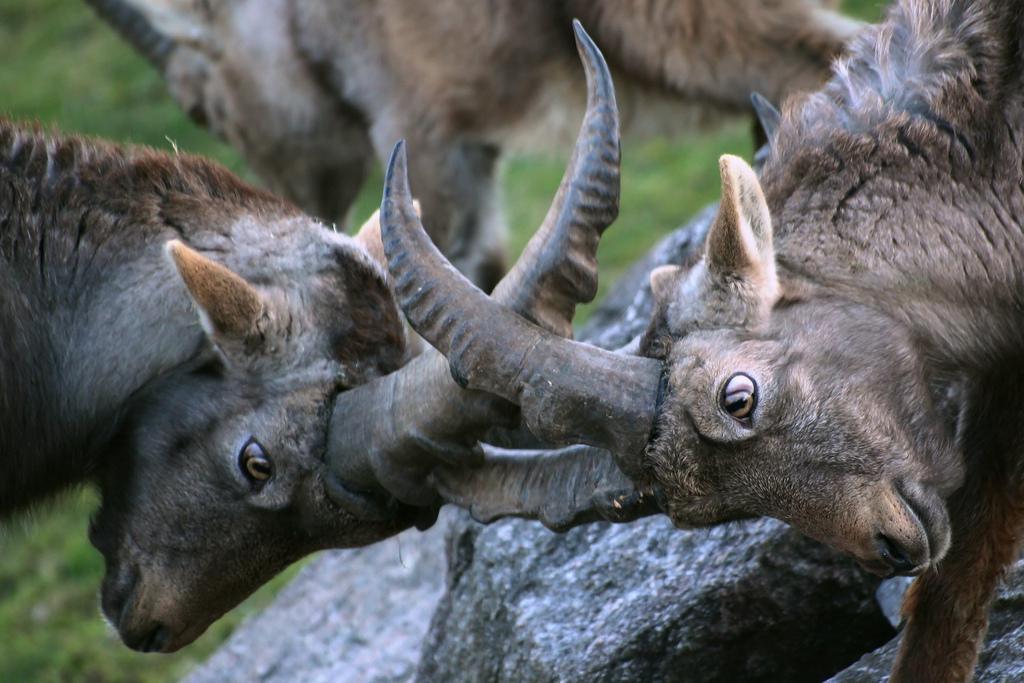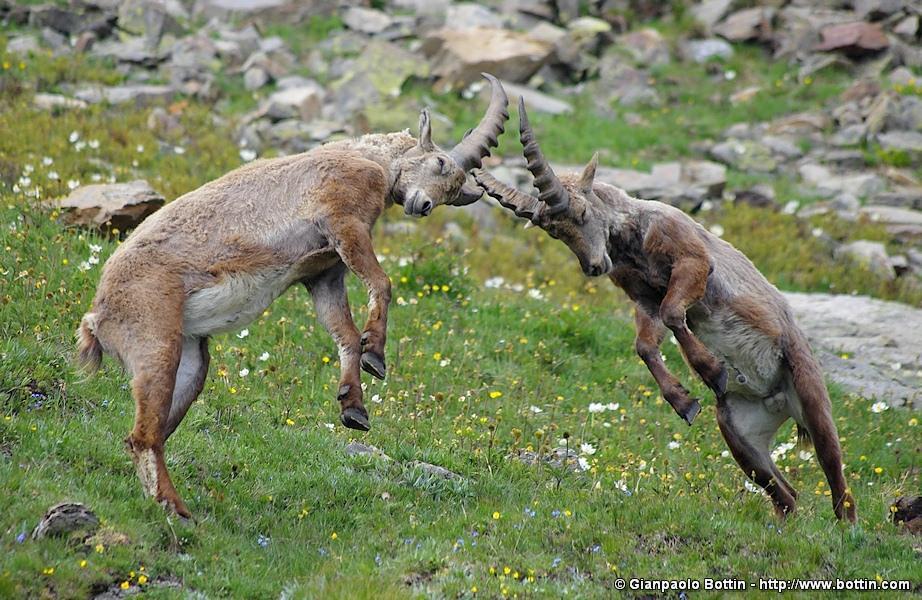The first image is the image on the left, the second image is the image on the right. Analyze the images presented: Is the assertion "There are three antelopes on a rocky mountain in the pair of images." valid? Answer yes or no. No. The first image is the image on the left, the second image is the image on the right. For the images displayed, is the sentence "All images show at least two horned animals in some kind of face-off, and in one image at least one animal has its front legs off the ground." factually correct? Answer yes or no. Yes. 